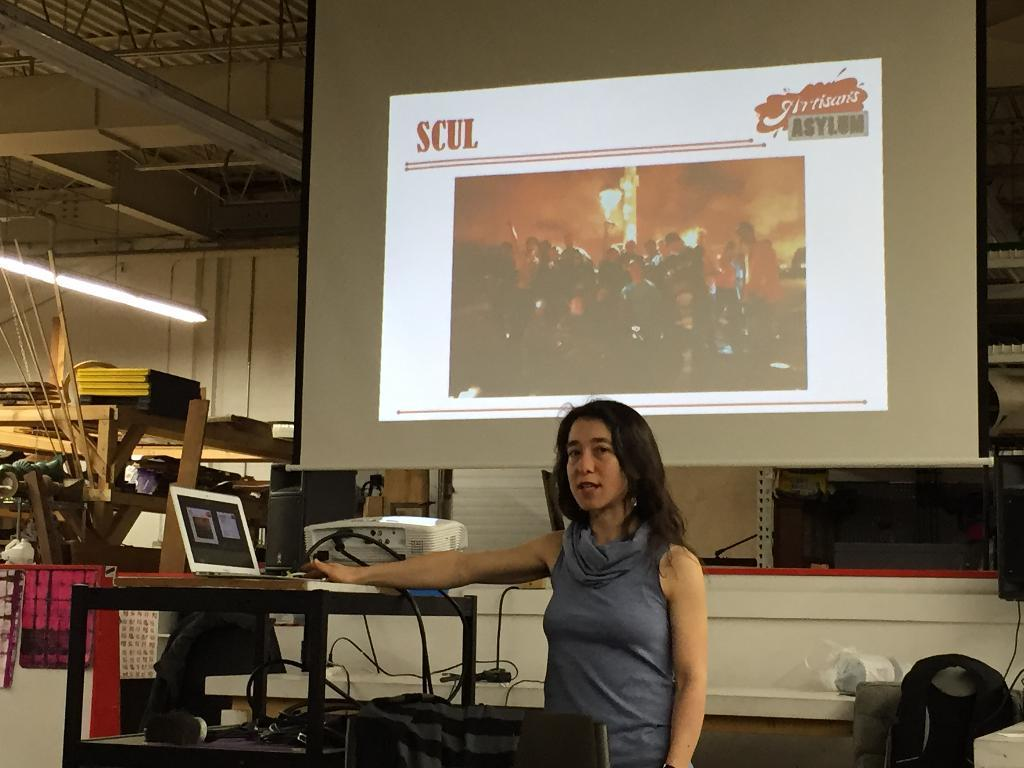<image>
Write a terse but informative summary of the picture. A woman is giving a presentation with a slide on the projector that says SCUL. 